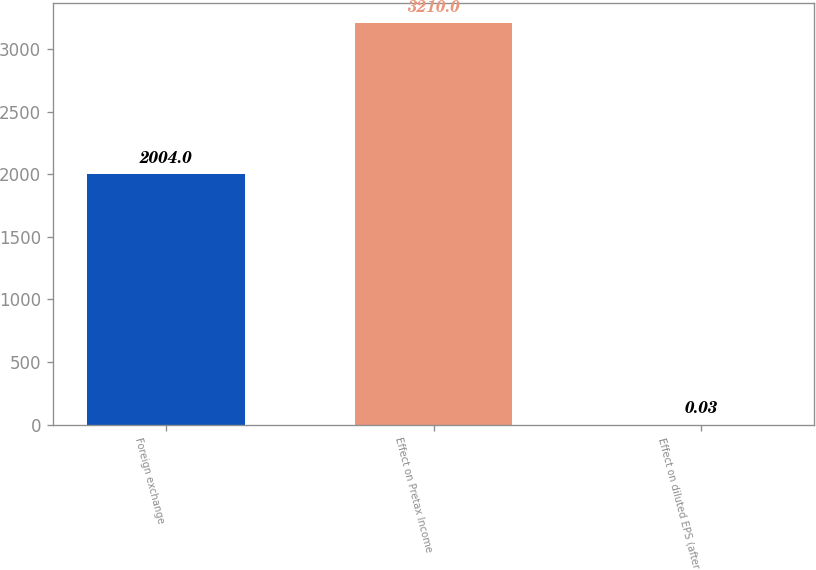<chart> <loc_0><loc_0><loc_500><loc_500><bar_chart><fcel>Foreign exchange<fcel>Effect on Pretax Income<fcel>Effect on diluted EPS (after<nl><fcel>2004<fcel>3210<fcel>0.03<nl></chart> 